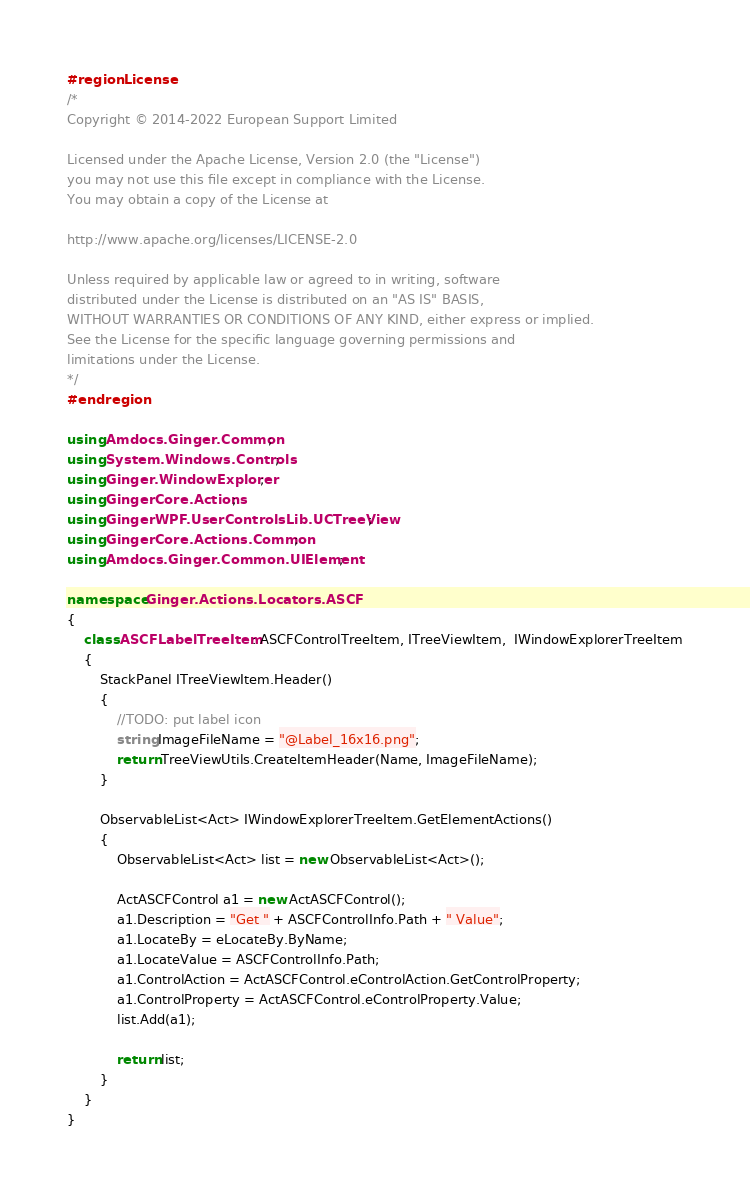Convert code to text. <code><loc_0><loc_0><loc_500><loc_500><_C#_>#region License
/*
Copyright © 2014-2022 European Support Limited

Licensed under the Apache License, Version 2.0 (the "License")
you may not use this file except in compliance with the License.
You may obtain a copy of the License at 

http://www.apache.org/licenses/LICENSE-2.0 

Unless required by applicable law or agreed to in writing, software
distributed under the License is distributed on an "AS IS" BASIS, 
WITHOUT WARRANTIES OR CONDITIONS OF ANY KIND, either express or implied. 
See the License for the specific language governing permissions and 
limitations under the License. 
*/
#endregion

using Amdocs.Ginger.Common;
using System.Windows.Controls;
using Ginger.WindowExplorer;
using GingerCore.Actions;
using GingerWPF.UserControlsLib.UCTreeView;
using GingerCore.Actions.Common;
using Amdocs.Ginger.Common.UIElement;

namespace Ginger.Actions.Locators.ASCF
{
    class ASCFLabelTreeItem : ASCFControlTreeItem, ITreeViewItem,  IWindowExplorerTreeItem
    {
        StackPanel ITreeViewItem.Header()
        {
            //TODO: put label icon
            string ImageFileName = "@Label_16x16.png";
            return TreeViewUtils.CreateItemHeader(Name, ImageFileName);
        }

        ObservableList<Act> IWindowExplorerTreeItem.GetElementActions()
        {
            ObservableList<Act> list = new ObservableList<Act>();

            ActASCFControl a1 = new ActASCFControl();
            a1.Description = "Get " + ASCFControlInfo.Path + " Value";
            a1.LocateBy = eLocateBy.ByName;
            a1.LocateValue = ASCFControlInfo.Path;            
            a1.ControlAction = ActASCFControl.eControlAction.GetControlProperty;
            a1.ControlProperty = ActASCFControl.eControlProperty.Value;
            list.Add(a1);

            return list;
        }
    }
}
</code> 